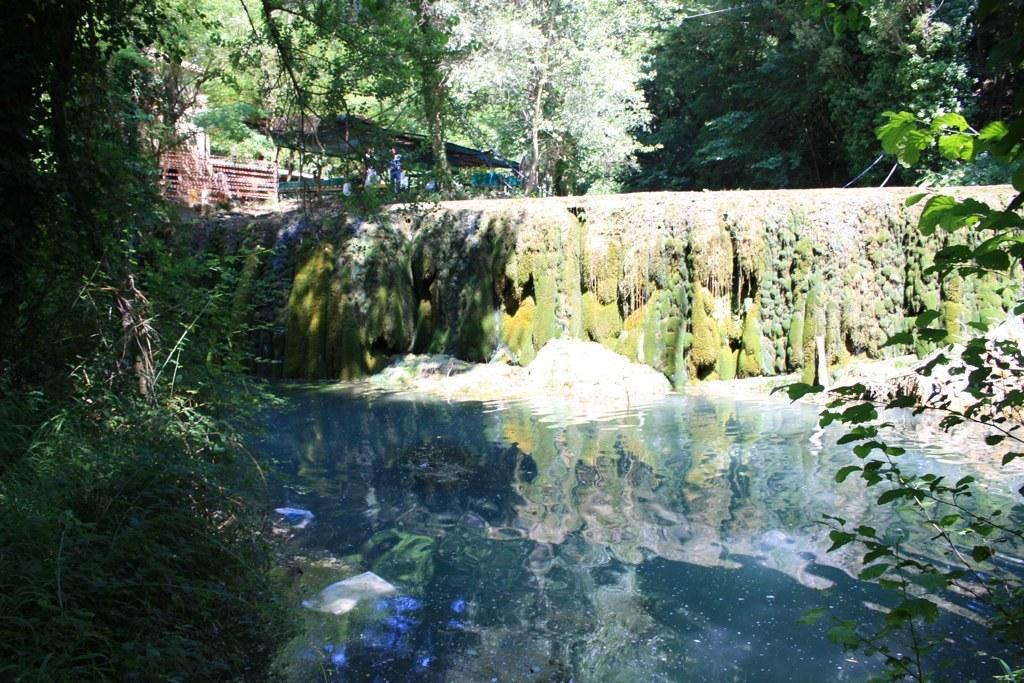In one or two sentences, can you explain what this image depicts? This picture is full of greenery. Here we can see a lake. these are the trees. Here we are able to see one shed and it seems like a sunny day. 